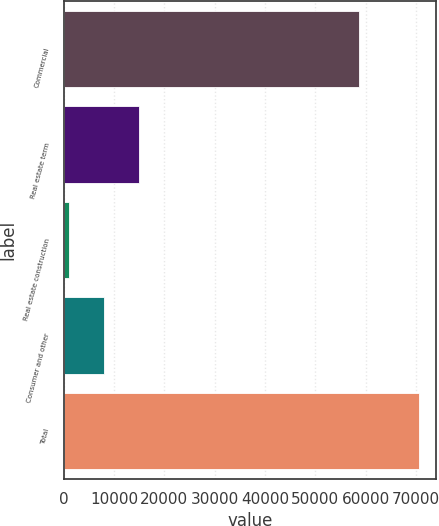Convert chart to OTSL. <chart><loc_0><loc_0><loc_500><loc_500><bar_chart><fcel>Commercial<fcel>Real estate term<fcel>Real estate construction<fcel>Consumer and other<fcel>Total<nl><fcel>58702<fcel>14912.8<fcel>1016<fcel>7964.4<fcel>70500<nl></chart> 